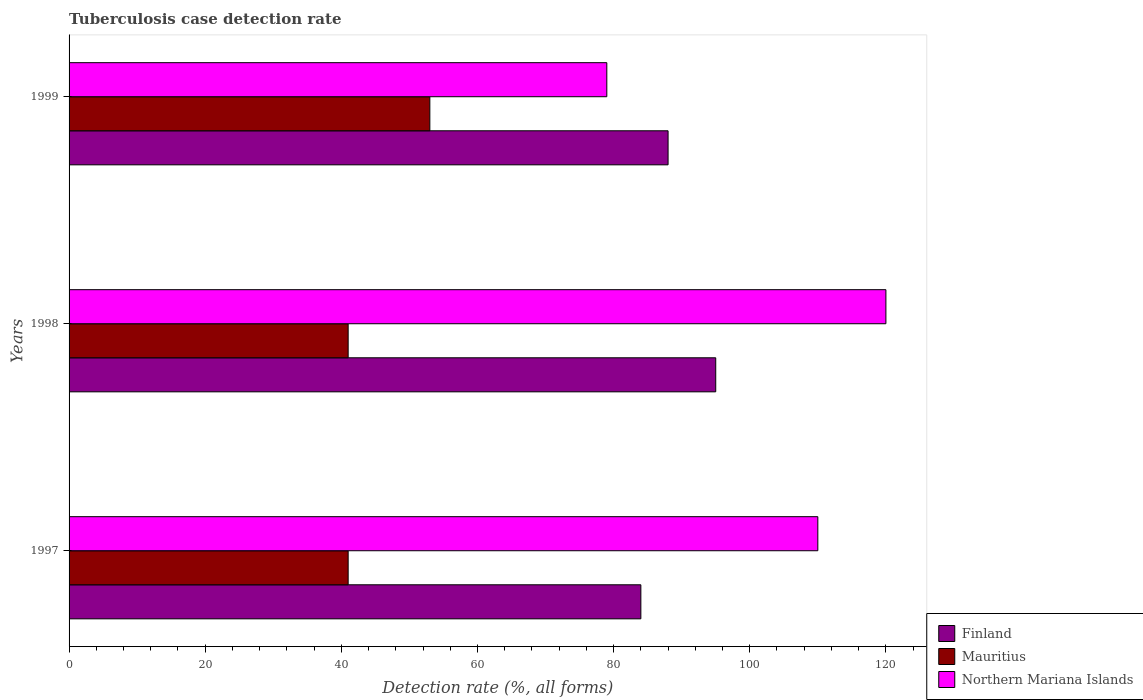How many different coloured bars are there?
Provide a short and direct response. 3. Are the number of bars per tick equal to the number of legend labels?
Ensure brevity in your answer.  Yes. How many bars are there on the 2nd tick from the top?
Give a very brief answer. 3. In how many cases, is the number of bars for a given year not equal to the number of legend labels?
Offer a very short reply. 0. What is the tuberculosis case detection rate in in Mauritius in 1997?
Make the answer very short. 41. Across all years, what is the maximum tuberculosis case detection rate in in Mauritius?
Keep it short and to the point. 53. Across all years, what is the minimum tuberculosis case detection rate in in Northern Mariana Islands?
Offer a terse response. 79. In which year was the tuberculosis case detection rate in in Northern Mariana Islands minimum?
Offer a terse response. 1999. What is the total tuberculosis case detection rate in in Northern Mariana Islands in the graph?
Keep it short and to the point. 309. What is the difference between the tuberculosis case detection rate in in Mauritius in 1997 and that in 1998?
Your answer should be compact. 0. What is the difference between the tuberculosis case detection rate in in Finland in 1998 and the tuberculosis case detection rate in in Mauritius in 1999?
Keep it short and to the point. 42. What is the average tuberculosis case detection rate in in Northern Mariana Islands per year?
Give a very brief answer. 103. In the year 1999, what is the difference between the tuberculosis case detection rate in in Finland and tuberculosis case detection rate in in Mauritius?
Your answer should be compact. 35. In how many years, is the tuberculosis case detection rate in in Finland greater than 8 %?
Give a very brief answer. 3. What is the ratio of the tuberculosis case detection rate in in Mauritius in 1997 to that in 1998?
Offer a terse response. 1. Is the tuberculosis case detection rate in in Northern Mariana Islands in 1997 less than that in 1999?
Offer a terse response. No. Is the difference between the tuberculosis case detection rate in in Finland in 1997 and 1998 greater than the difference between the tuberculosis case detection rate in in Mauritius in 1997 and 1998?
Give a very brief answer. No. What is the difference between the highest and the second highest tuberculosis case detection rate in in Finland?
Offer a terse response. 7. What is the difference between the highest and the lowest tuberculosis case detection rate in in Mauritius?
Your response must be concise. 12. In how many years, is the tuberculosis case detection rate in in Finland greater than the average tuberculosis case detection rate in in Finland taken over all years?
Ensure brevity in your answer.  1. What does the 3rd bar from the bottom in 1999 represents?
Keep it short and to the point. Northern Mariana Islands. Is it the case that in every year, the sum of the tuberculosis case detection rate in in Mauritius and tuberculosis case detection rate in in Finland is greater than the tuberculosis case detection rate in in Northern Mariana Islands?
Ensure brevity in your answer.  Yes. How many years are there in the graph?
Offer a very short reply. 3. Are the values on the major ticks of X-axis written in scientific E-notation?
Provide a short and direct response. No. Does the graph contain any zero values?
Make the answer very short. No. Does the graph contain grids?
Make the answer very short. No. How are the legend labels stacked?
Your answer should be compact. Vertical. What is the title of the graph?
Provide a succinct answer. Tuberculosis case detection rate. What is the label or title of the X-axis?
Ensure brevity in your answer.  Detection rate (%, all forms). What is the Detection rate (%, all forms) of Northern Mariana Islands in 1997?
Ensure brevity in your answer.  110. What is the Detection rate (%, all forms) in Mauritius in 1998?
Your response must be concise. 41. What is the Detection rate (%, all forms) of Northern Mariana Islands in 1998?
Make the answer very short. 120. What is the Detection rate (%, all forms) in Northern Mariana Islands in 1999?
Give a very brief answer. 79. Across all years, what is the maximum Detection rate (%, all forms) in Finland?
Your response must be concise. 95. Across all years, what is the maximum Detection rate (%, all forms) of Northern Mariana Islands?
Your answer should be very brief. 120. Across all years, what is the minimum Detection rate (%, all forms) of Finland?
Make the answer very short. 84. Across all years, what is the minimum Detection rate (%, all forms) of Mauritius?
Your response must be concise. 41. Across all years, what is the minimum Detection rate (%, all forms) in Northern Mariana Islands?
Provide a short and direct response. 79. What is the total Detection rate (%, all forms) of Finland in the graph?
Offer a very short reply. 267. What is the total Detection rate (%, all forms) of Mauritius in the graph?
Offer a terse response. 135. What is the total Detection rate (%, all forms) in Northern Mariana Islands in the graph?
Your answer should be compact. 309. What is the difference between the Detection rate (%, all forms) in Northern Mariana Islands in 1997 and that in 1998?
Ensure brevity in your answer.  -10. What is the difference between the Detection rate (%, all forms) of Finland in 1997 and that in 1999?
Provide a succinct answer. -4. What is the difference between the Detection rate (%, all forms) of Northern Mariana Islands in 1997 and that in 1999?
Ensure brevity in your answer.  31. What is the difference between the Detection rate (%, all forms) of Mauritius in 1998 and that in 1999?
Your response must be concise. -12. What is the difference between the Detection rate (%, all forms) in Finland in 1997 and the Detection rate (%, all forms) in Northern Mariana Islands in 1998?
Ensure brevity in your answer.  -36. What is the difference between the Detection rate (%, all forms) of Mauritius in 1997 and the Detection rate (%, all forms) of Northern Mariana Islands in 1998?
Your response must be concise. -79. What is the difference between the Detection rate (%, all forms) in Finland in 1997 and the Detection rate (%, all forms) in Mauritius in 1999?
Keep it short and to the point. 31. What is the difference between the Detection rate (%, all forms) of Finland in 1997 and the Detection rate (%, all forms) of Northern Mariana Islands in 1999?
Your answer should be compact. 5. What is the difference between the Detection rate (%, all forms) of Mauritius in 1997 and the Detection rate (%, all forms) of Northern Mariana Islands in 1999?
Your answer should be very brief. -38. What is the difference between the Detection rate (%, all forms) in Mauritius in 1998 and the Detection rate (%, all forms) in Northern Mariana Islands in 1999?
Your answer should be compact. -38. What is the average Detection rate (%, all forms) of Finland per year?
Provide a succinct answer. 89. What is the average Detection rate (%, all forms) of Mauritius per year?
Make the answer very short. 45. What is the average Detection rate (%, all forms) in Northern Mariana Islands per year?
Provide a succinct answer. 103. In the year 1997, what is the difference between the Detection rate (%, all forms) of Mauritius and Detection rate (%, all forms) of Northern Mariana Islands?
Keep it short and to the point. -69. In the year 1998, what is the difference between the Detection rate (%, all forms) in Mauritius and Detection rate (%, all forms) in Northern Mariana Islands?
Ensure brevity in your answer.  -79. In the year 1999, what is the difference between the Detection rate (%, all forms) in Finland and Detection rate (%, all forms) in Mauritius?
Offer a terse response. 35. In the year 1999, what is the difference between the Detection rate (%, all forms) in Finland and Detection rate (%, all forms) in Northern Mariana Islands?
Offer a terse response. 9. In the year 1999, what is the difference between the Detection rate (%, all forms) of Mauritius and Detection rate (%, all forms) of Northern Mariana Islands?
Make the answer very short. -26. What is the ratio of the Detection rate (%, all forms) of Finland in 1997 to that in 1998?
Give a very brief answer. 0.88. What is the ratio of the Detection rate (%, all forms) in Finland in 1997 to that in 1999?
Give a very brief answer. 0.95. What is the ratio of the Detection rate (%, all forms) of Mauritius in 1997 to that in 1999?
Provide a succinct answer. 0.77. What is the ratio of the Detection rate (%, all forms) in Northern Mariana Islands in 1997 to that in 1999?
Your answer should be compact. 1.39. What is the ratio of the Detection rate (%, all forms) of Finland in 1998 to that in 1999?
Offer a terse response. 1.08. What is the ratio of the Detection rate (%, all forms) of Mauritius in 1998 to that in 1999?
Provide a succinct answer. 0.77. What is the ratio of the Detection rate (%, all forms) in Northern Mariana Islands in 1998 to that in 1999?
Offer a terse response. 1.52. What is the difference between the highest and the second highest Detection rate (%, all forms) in Mauritius?
Keep it short and to the point. 12. What is the difference between the highest and the lowest Detection rate (%, all forms) of Finland?
Offer a terse response. 11. What is the difference between the highest and the lowest Detection rate (%, all forms) in Northern Mariana Islands?
Provide a short and direct response. 41. 